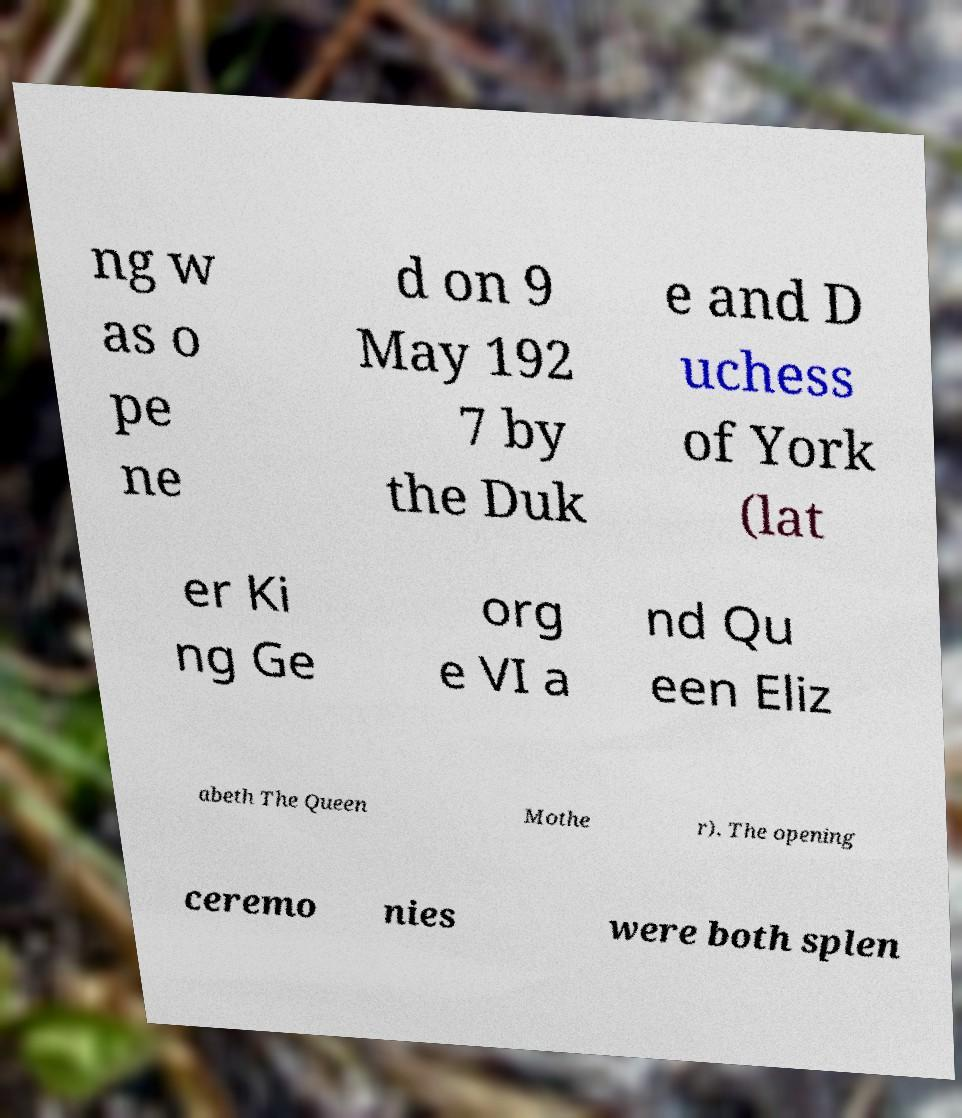Can you accurately transcribe the text from the provided image for me? ng w as o pe ne d on 9 May 192 7 by the Duk e and D uchess of York (lat er Ki ng Ge org e VI a nd Qu een Eliz abeth The Queen Mothe r). The opening ceremo nies were both splen 